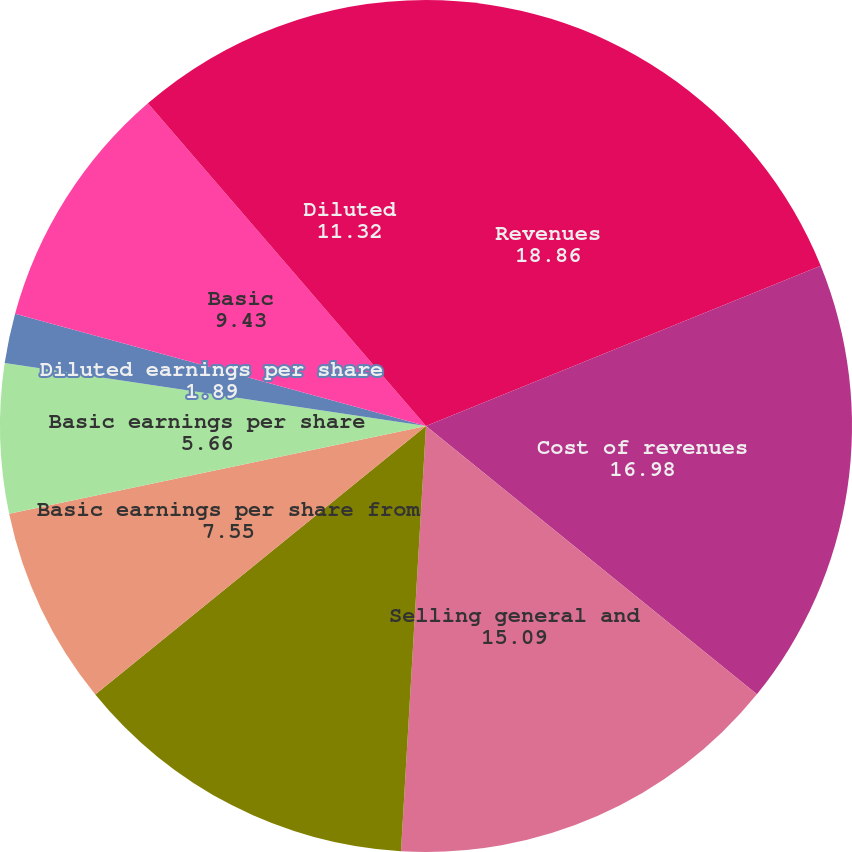Convert chart. <chart><loc_0><loc_0><loc_500><loc_500><pie_chart><fcel>Revenues<fcel>Cost of revenues<fcel>Selling general and<fcel>Net earnings<fcel>Basic earnings per share from<fcel>Basic earnings per share<fcel>Diluted earnings per share<fcel>Basic<fcel>Diluted<nl><fcel>18.86%<fcel>16.98%<fcel>15.09%<fcel>13.21%<fcel>7.55%<fcel>5.66%<fcel>1.89%<fcel>9.43%<fcel>11.32%<nl></chart> 